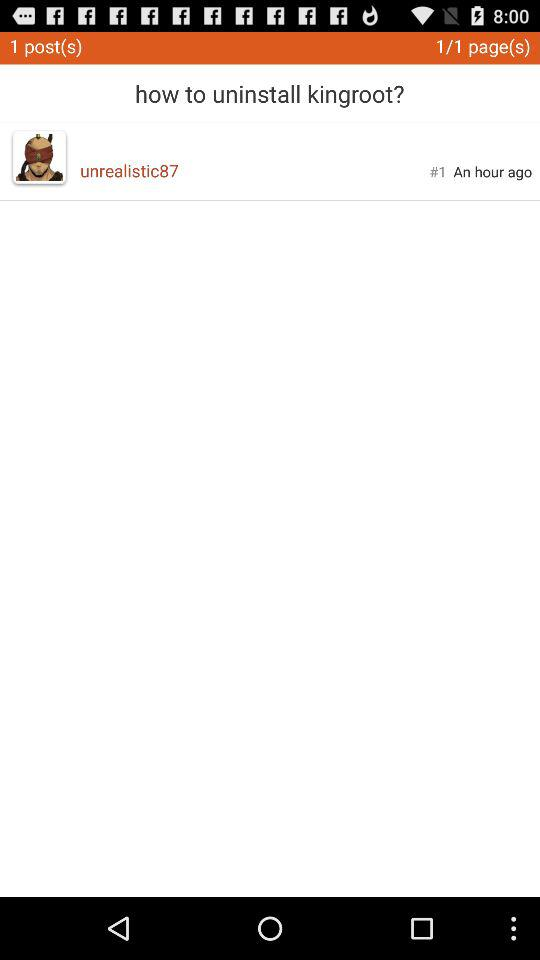What is the given username? The given username is "unrealistic87". 